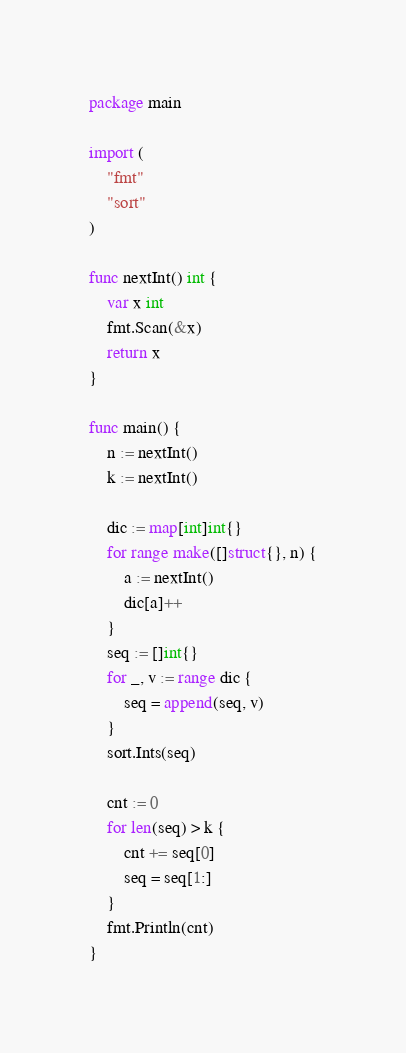Convert code to text. <code><loc_0><loc_0><loc_500><loc_500><_Go_>package main

import (
	"fmt"
	"sort"
)

func nextInt() int {
	var x int
	fmt.Scan(&x)
	return x
}

func main() {
	n := nextInt()
	k := nextInt()

	dic := map[int]int{}
	for range make([]struct{}, n) {
		a := nextInt()
		dic[a]++
	}
	seq := []int{}
	for _, v := range dic {
		seq = append(seq, v)
	}
	sort.Ints(seq)

	cnt := 0
	for len(seq) > k {
		cnt += seq[0]
		seq = seq[1:]
	}
	fmt.Println(cnt)
}
</code> 